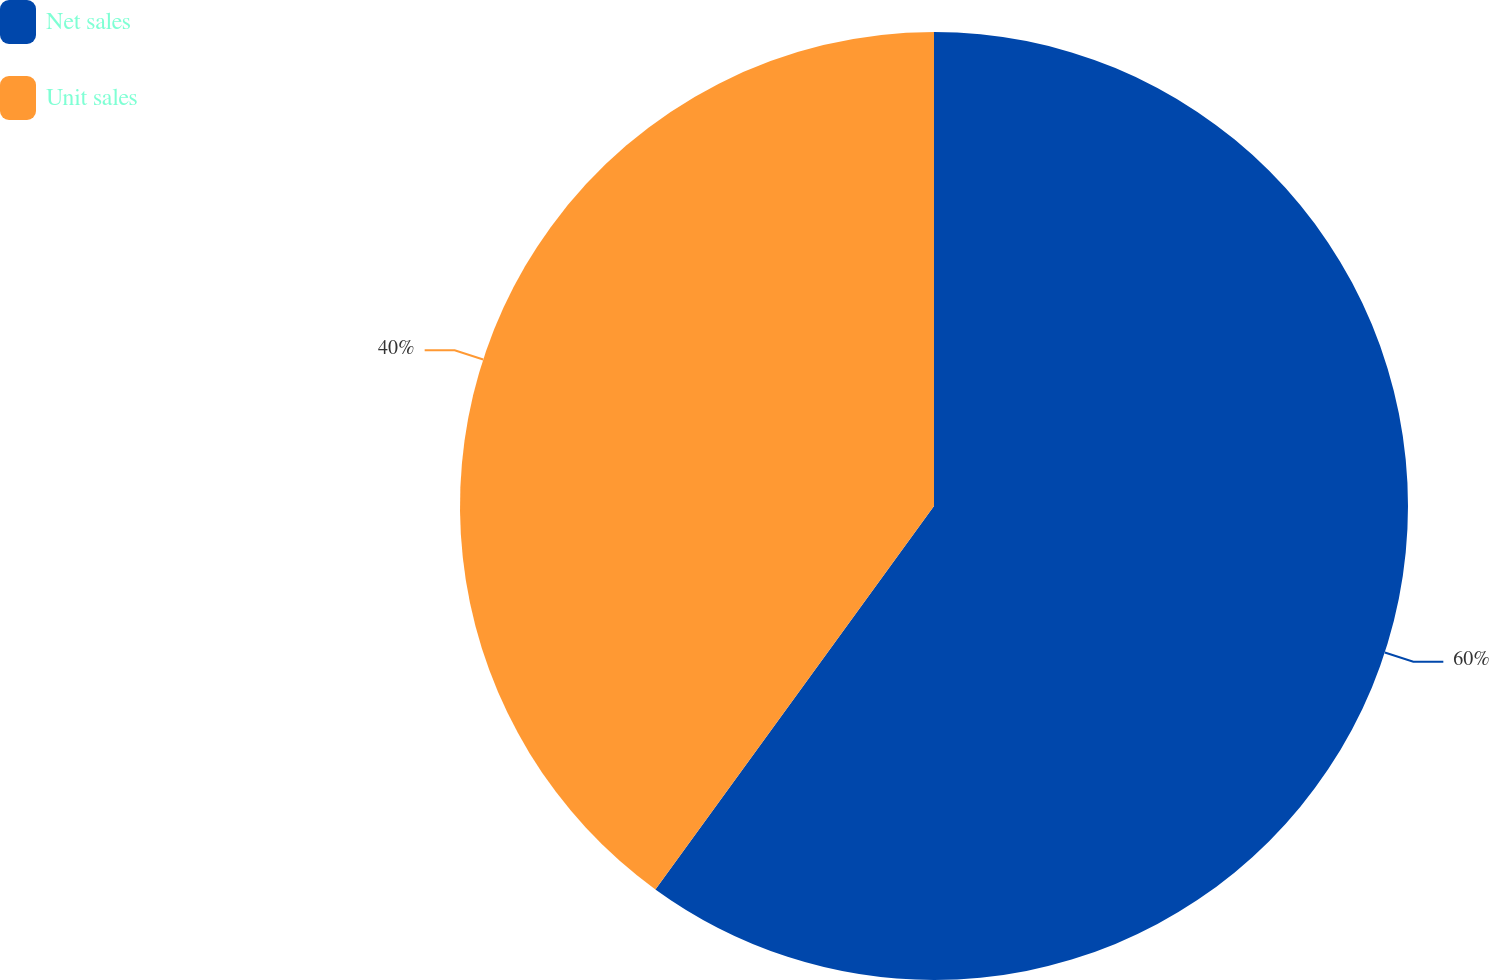Convert chart to OTSL. <chart><loc_0><loc_0><loc_500><loc_500><pie_chart><fcel>Net sales<fcel>Unit sales<nl><fcel>60.0%<fcel>40.0%<nl></chart> 